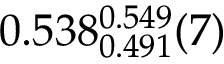Convert formula to latex. <formula><loc_0><loc_0><loc_500><loc_500>0 . 5 3 8 _ { 0 . 4 9 1 } ^ { 0 . 5 4 9 } ( 7 )</formula> 